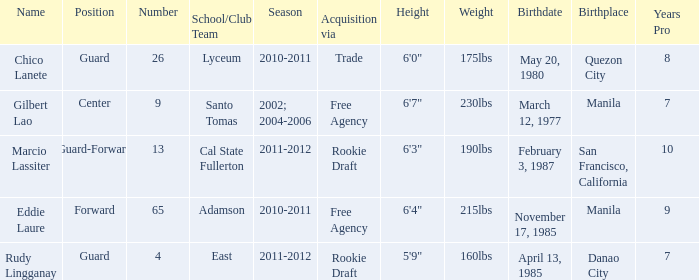What season had Marcio Lassiter? 2011-2012. 